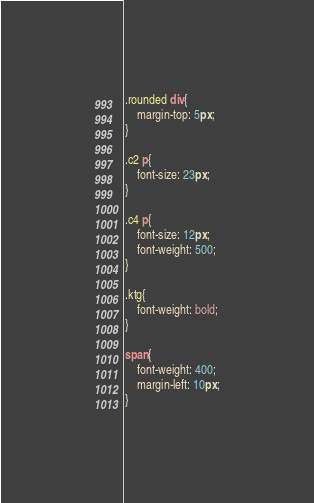Convert code to text. <code><loc_0><loc_0><loc_500><loc_500><_CSS_>
.rounded div{
    margin-top: 5px;
}

.c2 p{
    font-size: 23px;
}

.c4 p{
    font-size: 12px;
    font-weight: 500;
}

.ktg{
    font-weight: bold;
}

span{
    font-weight: 400;
    margin-left: 10px;
}

</code> 